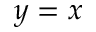Convert formula to latex. <formula><loc_0><loc_0><loc_500><loc_500>y = x</formula> 